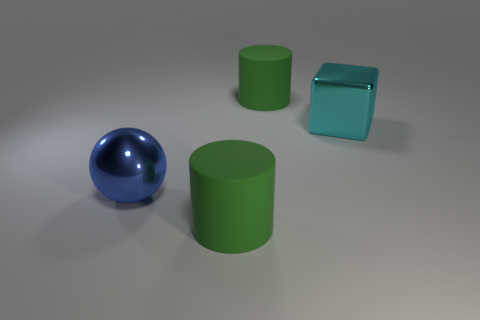Subtract all green cylinders. How many were subtracted if there are1green cylinders left? 1 Add 4 large metal blocks. How many objects exist? 8 Subtract all blocks. How many objects are left? 3 Subtract 1 green cylinders. How many objects are left? 3 Subtract 1 blocks. How many blocks are left? 0 Subtract all purple cubes. Subtract all gray cylinders. How many cubes are left? 1 Subtract all purple blocks. How many cyan cylinders are left? 0 Subtract all brown rubber things. Subtract all large matte objects. How many objects are left? 2 Add 3 large cylinders. How many large cylinders are left? 5 Add 1 metal things. How many metal things exist? 3 